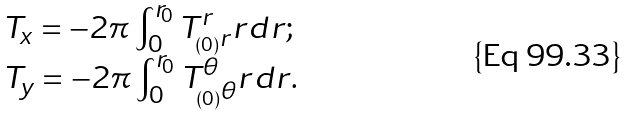Convert formula to latex. <formula><loc_0><loc_0><loc_500><loc_500>\begin{array} { l l } T _ { x } = - 2 \pi \int _ { 0 } ^ { r _ { 0 } } T ^ { r } _ { _ { ( 0 ) } r } r d r ; \\ T _ { y } = - 2 \pi \int _ { 0 } ^ { r _ { 0 } } T ^ { \theta } _ { _ { ( 0 ) } \theta } r d r . \end{array}</formula> 